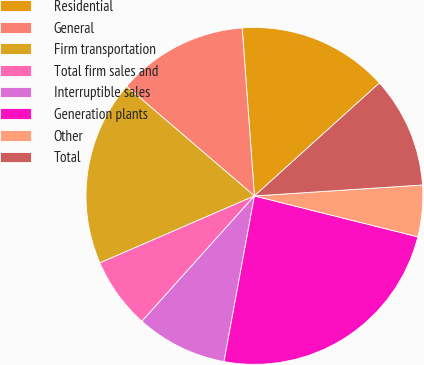Convert chart to OTSL. <chart><loc_0><loc_0><loc_500><loc_500><pie_chart><fcel>Residential<fcel>General<fcel>Firm transportation<fcel>Total firm sales and<fcel>Interruptible sales<fcel>Generation plants<fcel>Other<fcel>Total<nl><fcel>14.46%<fcel>12.56%<fcel>17.79%<fcel>6.85%<fcel>8.75%<fcel>23.99%<fcel>4.94%<fcel>10.66%<nl></chart> 